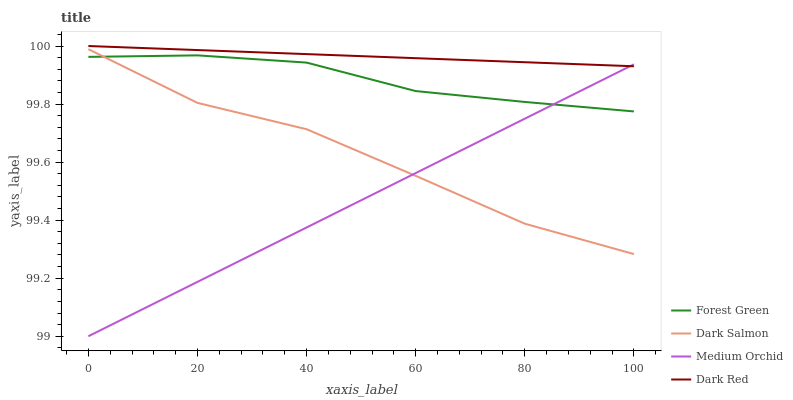Does Medium Orchid have the minimum area under the curve?
Answer yes or no. Yes. Does Dark Red have the maximum area under the curve?
Answer yes or no. Yes. Does Forest Green have the minimum area under the curve?
Answer yes or no. No. Does Forest Green have the maximum area under the curve?
Answer yes or no. No. Is Dark Red the smoothest?
Answer yes or no. Yes. Is Dark Salmon the roughest?
Answer yes or no. Yes. Is Forest Green the smoothest?
Answer yes or no. No. Is Forest Green the roughest?
Answer yes or no. No. Does Medium Orchid have the lowest value?
Answer yes or no. Yes. Does Forest Green have the lowest value?
Answer yes or no. No. Does Dark Red have the highest value?
Answer yes or no. Yes. Does Forest Green have the highest value?
Answer yes or no. No. Is Dark Salmon less than Dark Red?
Answer yes or no. Yes. Is Dark Red greater than Dark Salmon?
Answer yes or no. Yes. Does Dark Salmon intersect Forest Green?
Answer yes or no. Yes. Is Dark Salmon less than Forest Green?
Answer yes or no. No. Is Dark Salmon greater than Forest Green?
Answer yes or no. No. Does Dark Salmon intersect Dark Red?
Answer yes or no. No. 